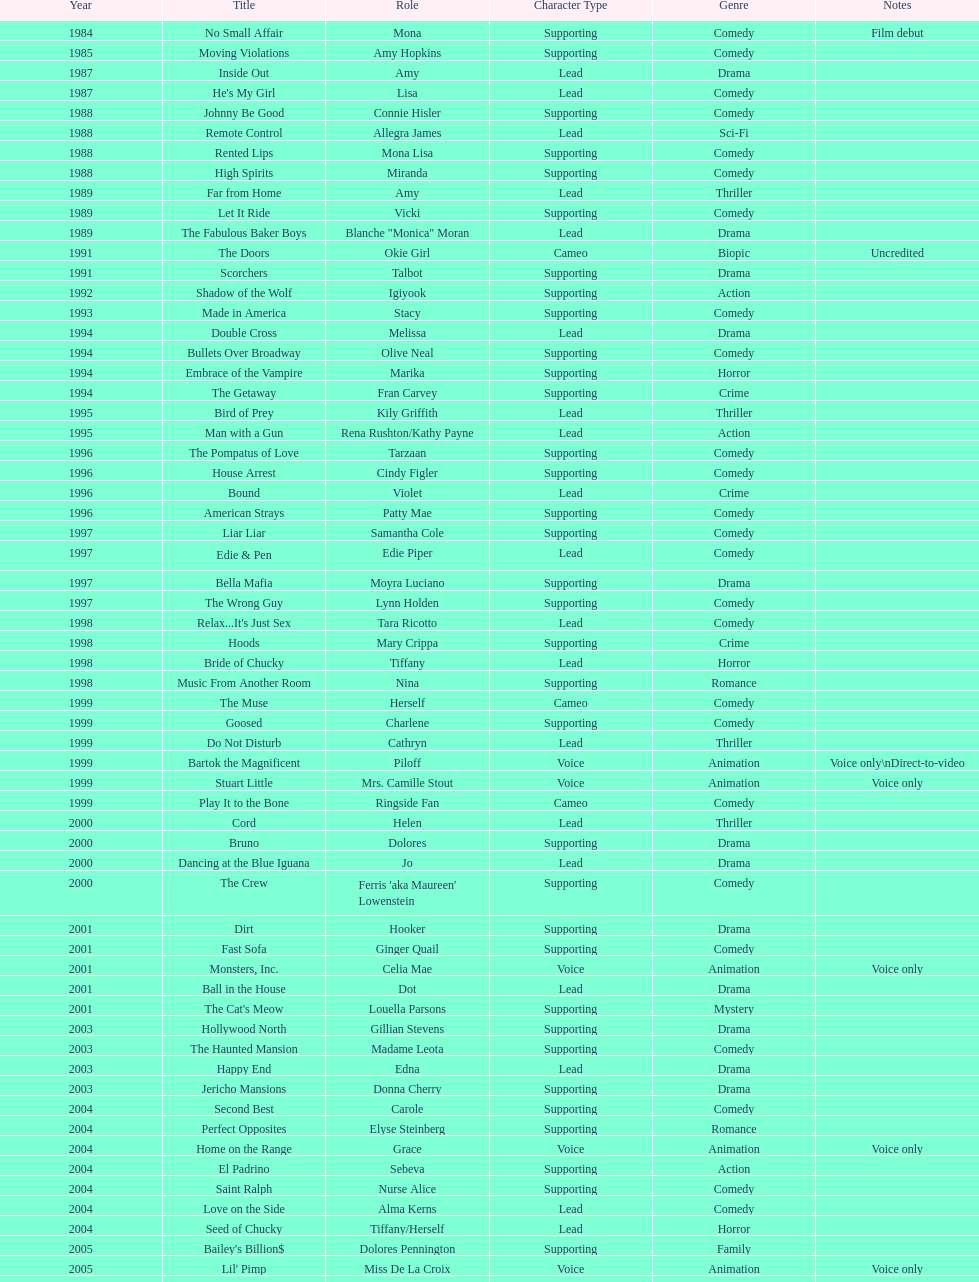How many movies does jennifer tilly play herself? 4. 